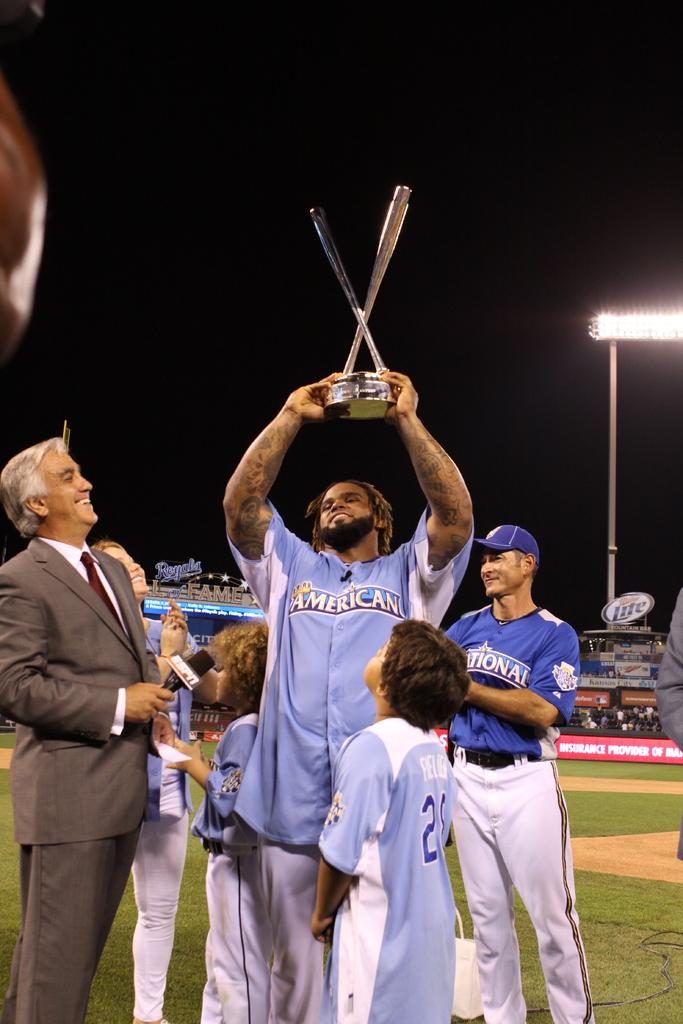Does the man in back shirt's say "national:?
Offer a terse response. Yes. 